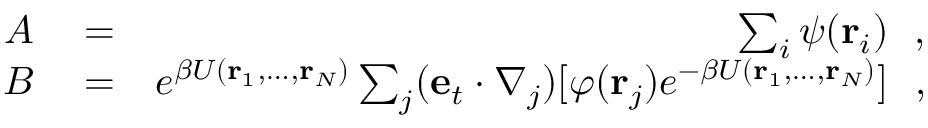<formula> <loc_0><loc_0><loc_500><loc_500>\begin{array} { r l r } { A } & = } & { \sum _ { i } \psi ( { r } _ { i } ) , } \\ { B } & = } & { e ^ { \beta U ( { r } _ { 1 } , \dots , { r } _ { N } ) } \sum _ { j } ( { e } _ { t } \cdot \nabla _ { j } ) [ \varphi ( { r } _ { j } ) e ^ { - \beta U ( { r } _ { 1 } , \dots , { r } _ { N } ) } ] , } \end{array}</formula> 